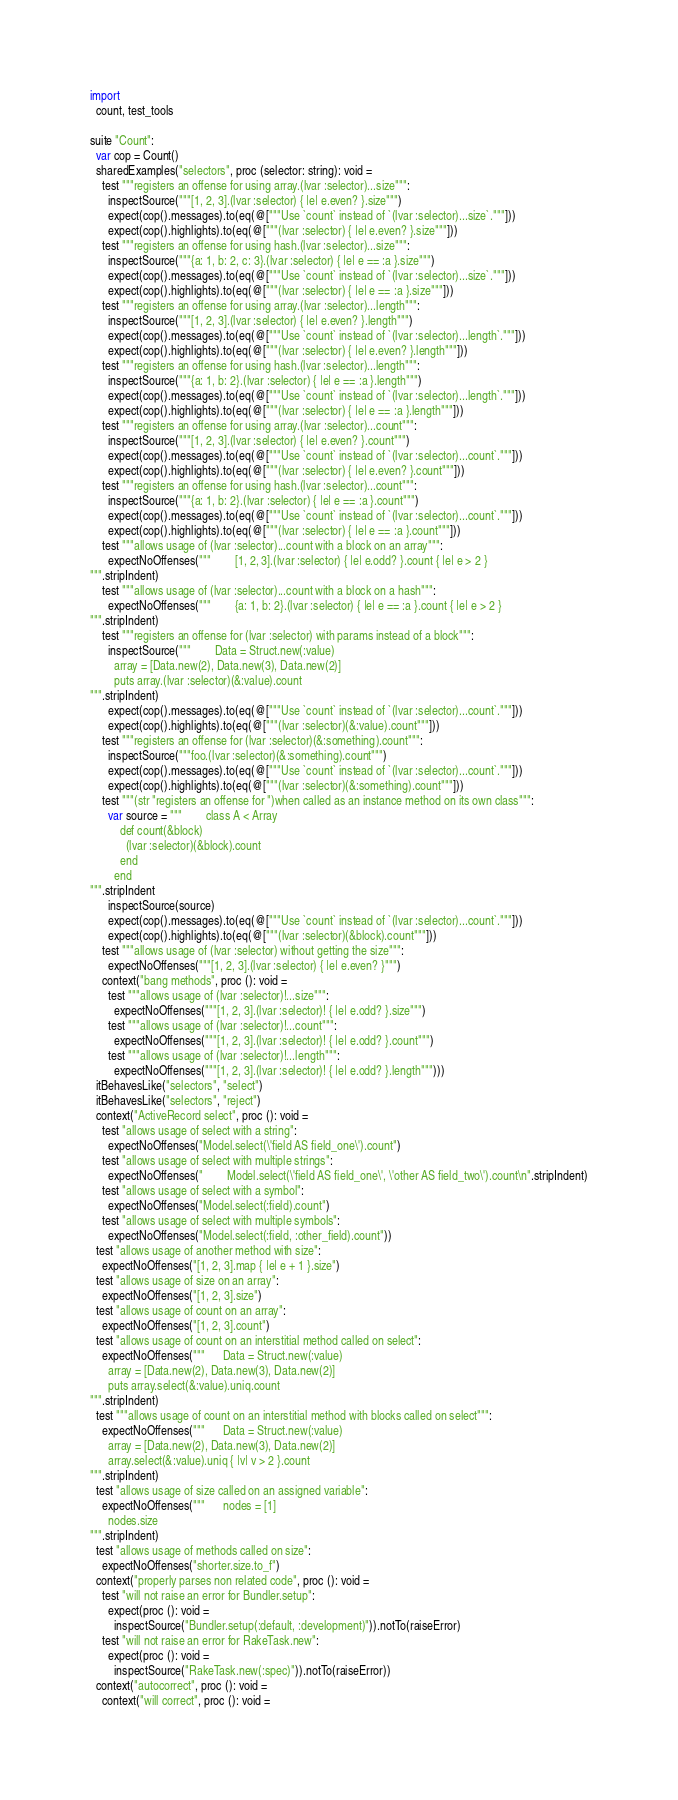Convert code to text. <code><loc_0><loc_0><loc_500><loc_500><_Nim_>
import
  count, test_tools

suite "Count":
  var cop = Count()
  sharedExamples("selectors", proc (selector: string): void =
    test """registers an offense for using array.(lvar :selector)...size""":
      inspectSource("""[1, 2, 3].(lvar :selector) { |e| e.even? }.size""")
      expect(cop().messages).to(eq(@["""Use `count` instead of `(lvar :selector)...size`."""]))
      expect(cop().highlights).to(eq(@["""(lvar :selector) { |e| e.even? }.size"""]))
    test """registers an offense for using hash.(lvar :selector)...size""":
      inspectSource("""{a: 1, b: 2, c: 3}.(lvar :selector) { |e| e == :a }.size""")
      expect(cop().messages).to(eq(@["""Use `count` instead of `(lvar :selector)...size`."""]))
      expect(cop().highlights).to(eq(@["""(lvar :selector) { |e| e == :a }.size"""]))
    test """registers an offense for using array.(lvar :selector)...length""":
      inspectSource("""[1, 2, 3].(lvar :selector) { |e| e.even? }.length""")
      expect(cop().messages).to(eq(@["""Use `count` instead of `(lvar :selector)...length`."""]))
      expect(cop().highlights).to(eq(@["""(lvar :selector) { |e| e.even? }.length"""]))
    test """registers an offense for using hash.(lvar :selector)...length""":
      inspectSource("""{a: 1, b: 2}.(lvar :selector) { |e| e == :a }.length""")
      expect(cop().messages).to(eq(@["""Use `count` instead of `(lvar :selector)...length`."""]))
      expect(cop().highlights).to(eq(@["""(lvar :selector) { |e| e == :a }.length"""]))
    test """registers an offense for using array.(lvar :selector)...count""":
      inspectSource("""[1, 2, 3].(lvar :selector) { |e| e.even? }.count""")
      expect(cop().messages).to(eq(@["""Use `count` instead of `(lvar :selector)...count`."""]))
      expect(cop().highlights).to(eq(@["""(lvar :selector) { |e| e.even? }.count"""]))
    test """registers an offense for using hash.(lvar :selector)...count""":
      inspectSource("""{a: 1, b: 2}.(lvar :selector) { |e| e == :a }.count""")
      expect(cop().messages).to(eq(@["""Use `count` instead of `(lvar :selector)...count`."""]))
      expect(cop().highlights).to(eq(@["""(lvar :selector) { |e| e == :a }.count"""]))
    test """allows usage of (lvar :selector)...count with a block on an array""":
      expectNoOffenses("""        [1, 2, 3].(lvar :selector) { |e| e.odd? }.count { |e| e > 2 }
""".stripIndent)
    test """allows usage of (lvar :selector)...count with a block on a hash""":
      expectNoOffenses("""        {a: 1, b: 2}.(lvar :selector) { |e| e == :a }.count { |e| e > 2 }
""".stripIndent)
    test """registers an offense for (lvar :selector) with params instead of a block""":
      inspectSource("""        Data = Struct.new(:value)
        array = [Data.new(2), Data.new(3), Data.new(2)]
        puts array.(lvar :selector)(&:value).count
""".stripIndent)
      expect(cop().messages).to(eq(@["""Use `count` instead of `(lvar :selector)...count`."""]))
      expect(cop().highlights).to(eq(@["""(lvar :selector)(&:value).count"""]))
    test """registers an offense for (lvar :selector)(&:something).count""":
      inspectSource("""foo.(lvar :selector)(&:something).count""")
      expect(cop().messages).to(eq(@["""Use `count` instead of `(lvar :selector)...count`."""]))
      expect(cop().highlights).to(eq(@["""(lvar :selector)(&:something).count"""]))
    test """(str "registers an offense for ")when called as an instance method on its own class""":
      var source = """        class A < Array
          def count(&block)
            (lvar :selector)(&block).count
          end
        end
""".stripIndent
      inspectSource(source)
      expect(cop().messages).to(eq(@["""Use `count` instead of `(lvar :selector)...count`."""]))
      expect(cop().highlights).to(eq(@["""(lvar :selector)(&block).count"""]))
    test """allows usage of (lvar :selector) without getting the size""":
      expectNoOffenses("""[1, 2, 3].(lvar :selector) { |e| e.even? }""")
    context("bang methods", proc (): void =
      test """allows usage of (lvar :selector)!...size""":
        expectNoOffenses("""[1, 2, 3].(lvar :selector)! { |e| e.odd? }.size""")
      test """allows usage of (lvar :selector)!...count""":
        expectNoOffenses("""[1, 2, 3].(lvar :selector)! { |e| e.odd? }.count""")
      test """allows usage of (lvar :selector)!...length""":
        expectNoOffenses("""[1, 2, 3].(lvar :selector)! { |e| e.odd? }.length""")))
  itBehavesLike("selectors", "select")
  itBehavesLike("selectors", "reject")
  context("ActiveRecord select", proc (): void =
    test "allows usage of select with a string":
      expectNoOffenses("Model.select(\'field AS field_one\').count")
    test "allows usage of select with multiple strings":
      expectNoOffenses("        Model.select(\'field AS field_one\', \'other AS field_two\').count\n".stripIndent)
    test "allows usage of select with a symbol":
      expectNoOffenses("Model.select(:field).count")
    test "allows usage of select with multiple symbols":
      expectNoOffenses("Model.select(:field, :other_field).count"))
  test "allows usage of another method with size":
    expectNoOffenses("[1, 2, 3].map { |e| e + 1 }.size")
  test "allows usage of size on an array":
    expectNoOffenses("[1, 2, 3].size")
  test "allows usage of count on an array":
    expectNoOffenses("[1, 2, 3].count")
  test "allows usage of count on an interstitial method called on select":
    expectNoOffenses("""      Data = Struct.new(:value)
      array = [Data.new(2), Data.new(3), Data.new(2)]
      puts array.select(&:value).uniq.count
""".stripIndent)
  test """allows usage of count on an interstitial method with blocks called on select""":
    expectNoOffenses("""      Data = Struct.new(:value)
      array = [Data.new(2), Data.new(3), Data.new(2)]
      array.select(&:value).uniq { |v| v > 2 }.count
""".stripIndent)
  test "allows usage of size called on an assigned variable":
    expectNoOffenses("""      nodes = [1]
      nodes.size
""".stripIndent)
  test "allows usage of methods called on size":
    expectNoOffenses("shorter.size.to_f")
  context("properly parses non related code", proc (): void =
    test "will not raise an error for Bundler.setup":
      expect(proc (): void =
        inspectSource("Bundler.setup(:default, :development)")).notTo(raiseError)
    test "will not raise an error for RakeTask.new":
      expect(proc (): void =
        inspectSource("RakeTask.new(:spec)")).notTo(raiseError))
  context("autocorrect", proc (): void =
    context("will correct", proc (): void =</code> 